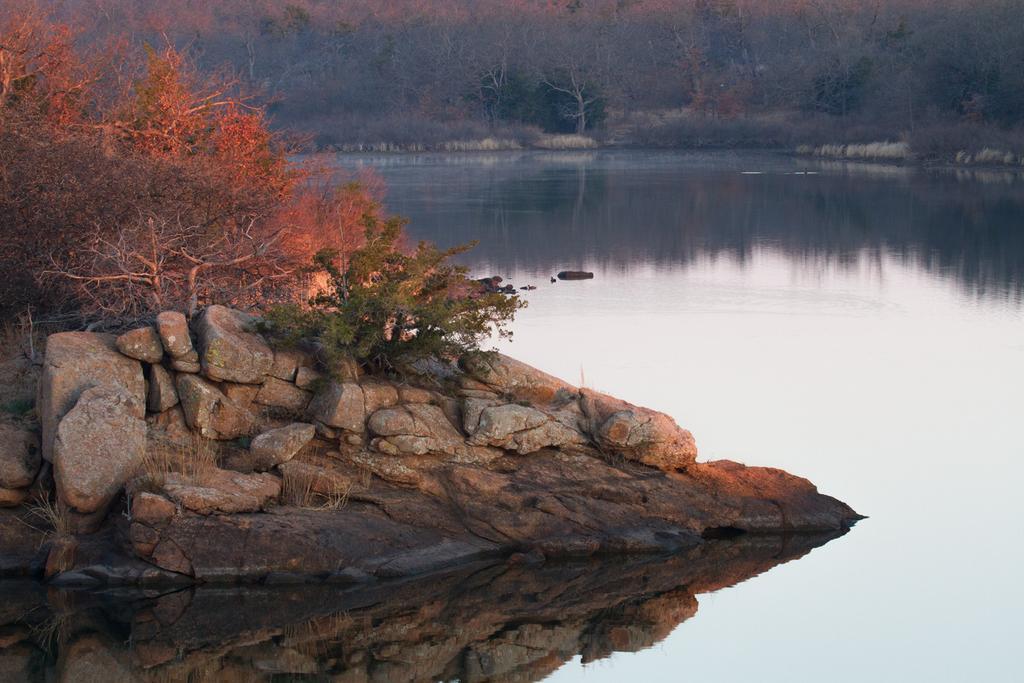Describe this image in one or two sentences. In this image on the left, there are stones and trees. On the right, there are trees, plants, water. 